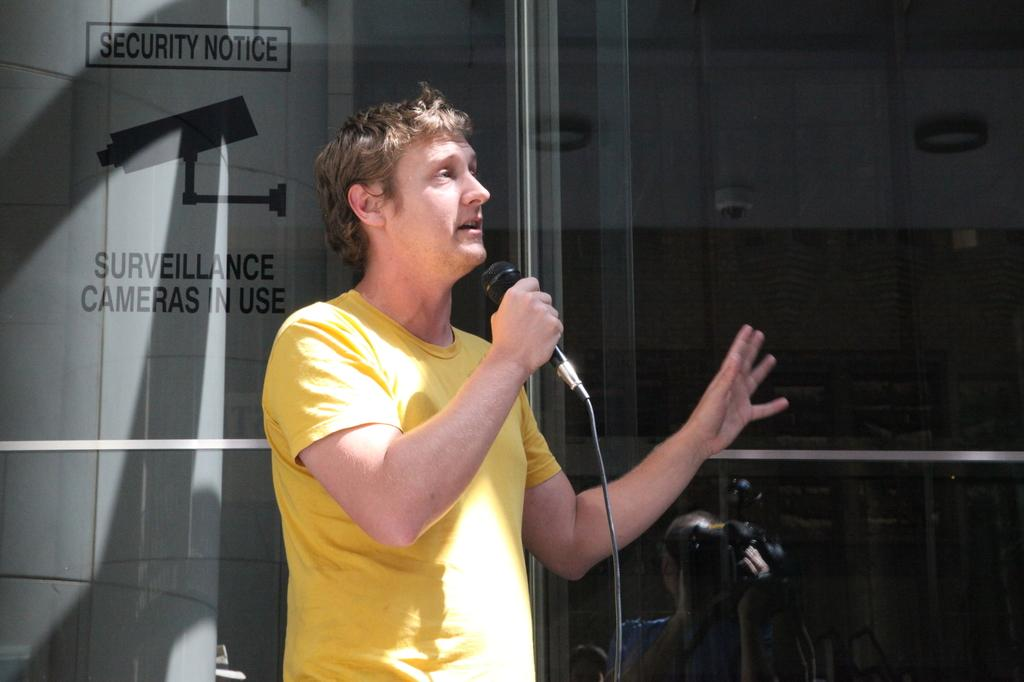What is the person in the image doing? The person in the image is talking on a mic. Can you describe any other features of the image? Yes, there is a glass door visible in the image. What type of thing can be seen floating in the waves in the image? There are no waves or things floating in them present in the image. 